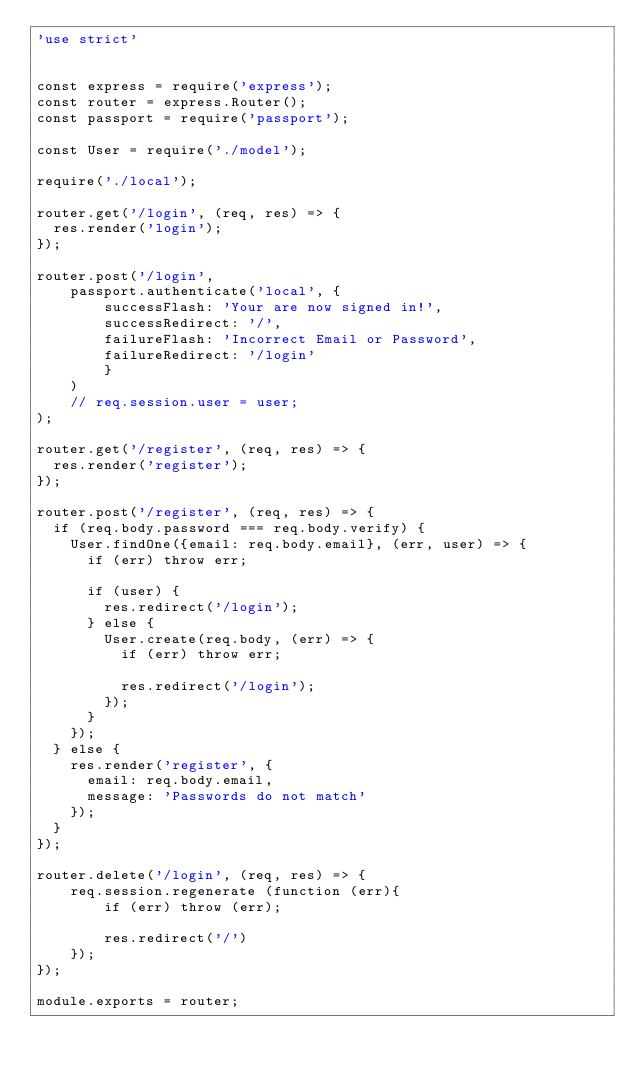<code> <loc_0><loc_0><loc_500><loc_500><_JavaScript_>'use strict'


const express = require('express');
const router = express.Router();
const passport = require('passport');

const User = require('./model');

require('./local');

router.get('/login', (req, res) => {
  res.render('login');
});

router.post('/login',
    passport.authenticate('local', {
        successFlash: 'Your are now signed in!',
        successRedirect: '/',
        failureFlash: 'Incorrect Email or Password',
        failureRedirect: '/login'
        }
    )
    // req.session.user = user;
);

router.get('/register', (req, res) => {
  res.render('register');
});

router.post('/register', (req, res) => {
  if (req.body.password === req.body.verify) {
    User.findOne({email: req.body.email}, (err, user) => {
      if (err) throw err;

      if (user) {
        res.redirect('/login');
      } else {
        User.create(req.body, (err) => {
          if (err) throw err;

          res.redirect('/login');
        });
      }
    });
  } else {
    res.render('register', {
      email: req.body.email,
      message: 'Passwords do not match'
    });
  }
});

router.delete('/login', (req, res) => {
    req.session.regenerate (function (err){
        if (err) throw (err);

        res.redirect('/')
    });
});

module.exports = router;

</code> 